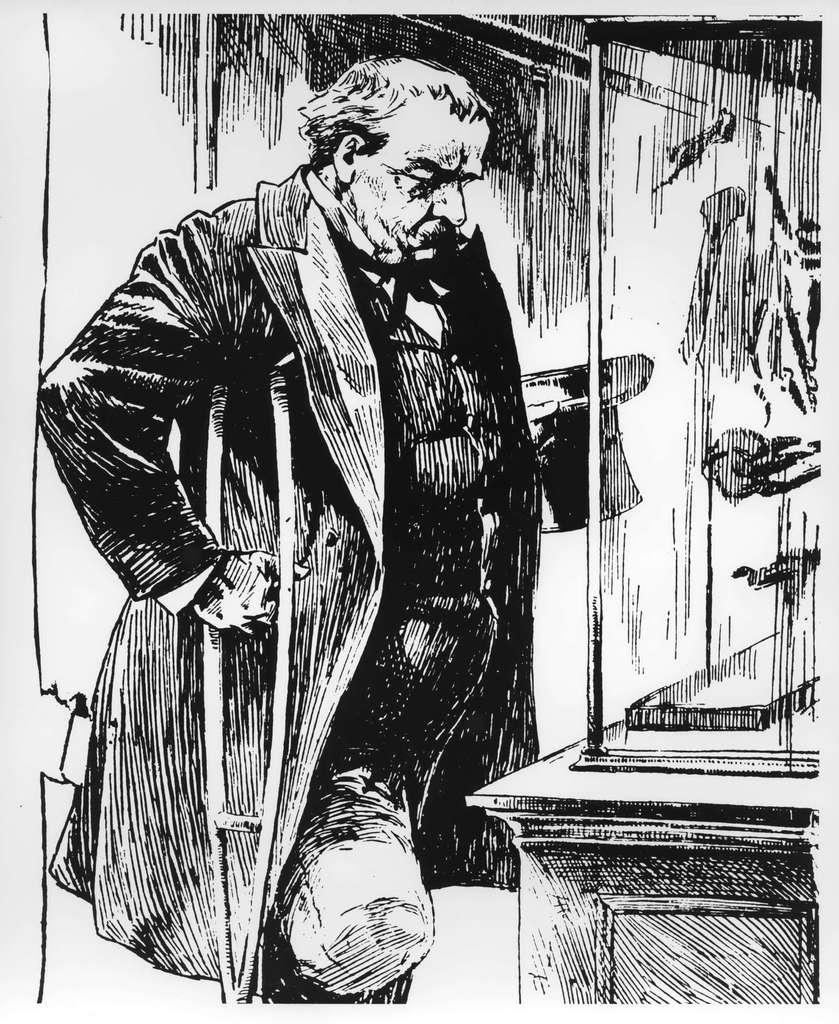What type of artwork is depicted in the image? The image is a sketch. How many fingers can be seen on the pencil in the image? There is no pencil present in the image, and therefore no fingers can be seen on it. 